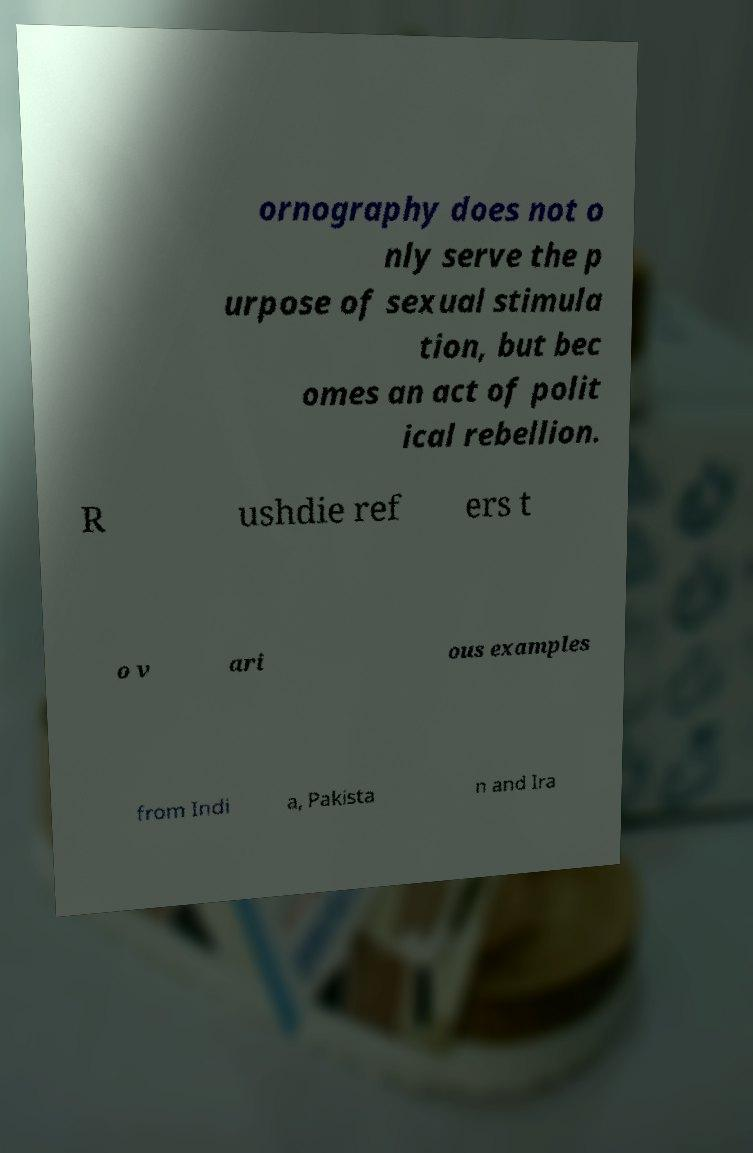For documentation purposes, I need the text within this image transcribed. Could you provide that? ornography does not o nly serve the p urpose of sexual stimula tion, but bec omes an act of polit ical rebellion. R ushdie ref ers t o v ari ous examples from Indi a, Pakista n and Ira 